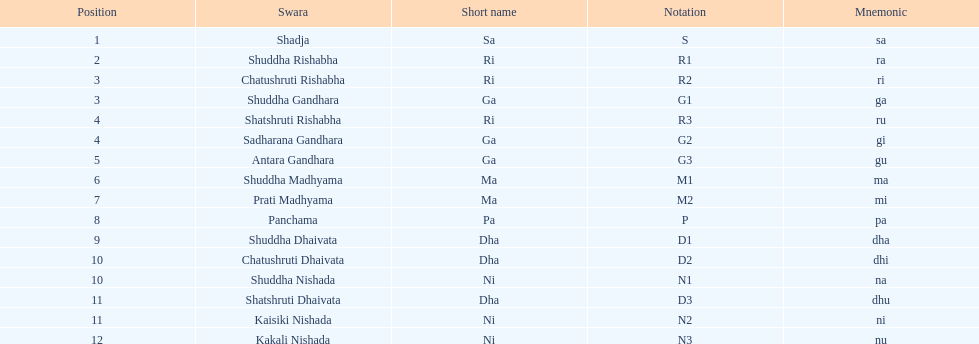Catalog all pairs of swaras with identical positions. Chatushruti Rishabha, Shuddha Gandhara, Shatshruti Rishabha, Sadharana Gandhara, Chatushruti Dhaivata, Shuddha Nishada, Shatshruti Dhaivata, Kaisiki Nishada. 